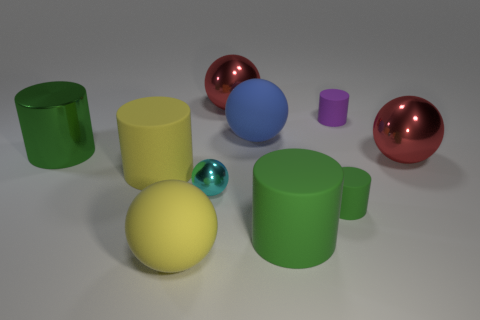There is a large thing that is the same color as the shiny cylinder; what is its material?
Provide a short and direct response. Rubber. What size is the cyan metal object?
Your answer should be very brief. Small. What material is the cylinder that is the same size as the purple thing?
Ensure brevity in your answer.  Rubber. The large metal ball to the left of the large blue sphere is what color?
Your answer should be compact. Red. How many tiny cyan metal spheres are there?
Offer a terse response. 1. Are there any small rubber cylinders that are on the left side of the red thing behind the cylinder behind the large blue ball?
Your answer should be very brief. No. There is a metal thing that is the same size as the purple cylinder; what is its shape?
Provide a short and direct response. Sphere. What number of other objects are there of the same color as the tiny ball?
Ensure brevity in your answer.  0. What is the small green cylinder made of?
Keep it short and to the point. Rubber. What number of other things are made of the same material as the large blue ball?
Offer a terse response. 5. 